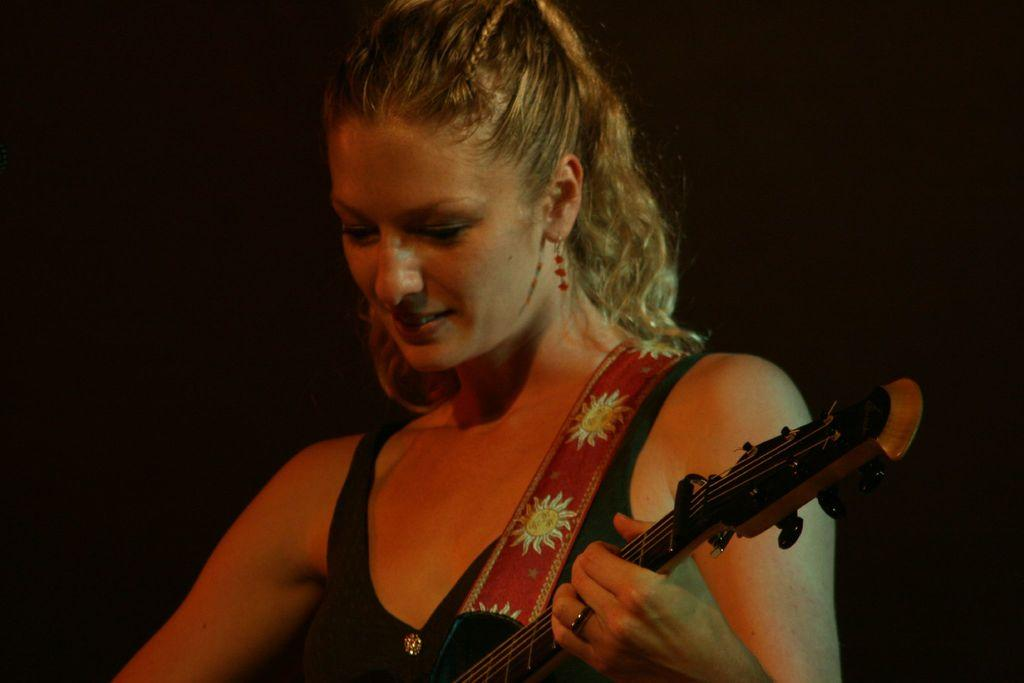What is the main subject of the image? The main subject of the image is a woman. What is the woman holding in the image? The woman is holding a guitar with her hands. What type of ornament is the woman wearing on her head in the image? There is no ornament visible on the woman's head in the image. How many copies of the guitar does the woman have in the image? The woman is holding only one guitar in the image, so there are no copies of the guitar. 